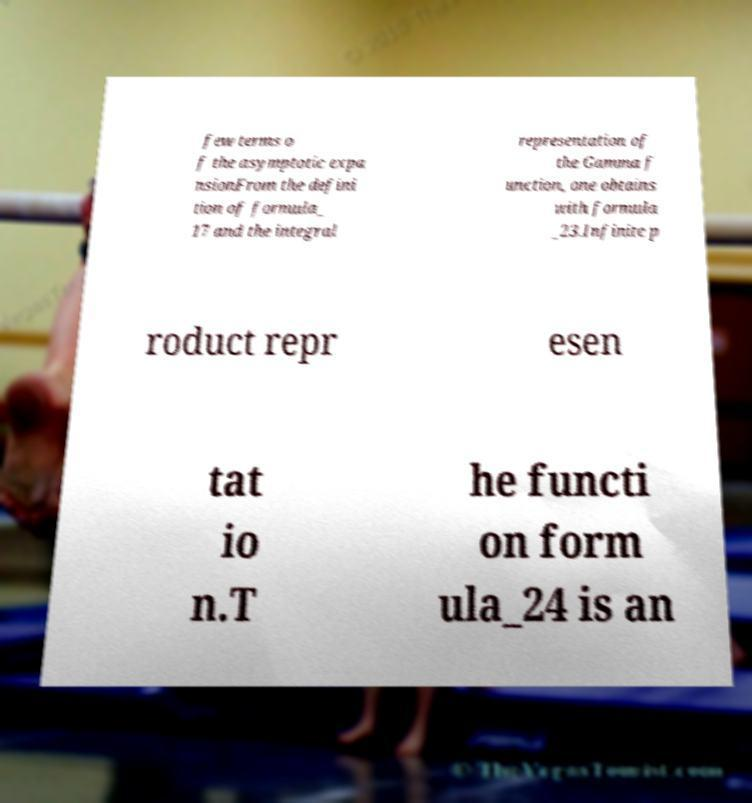Can you accurately transcribe the text from the provided image for me? few terms o f the asymptotic expa nsionFrom the defini tion of formula_ 17 and the integral representation of the Gamma f unction, one obtains with formula _23.Infinite p roduct repr esen tat io n.T he functi on form ula_24 is an 